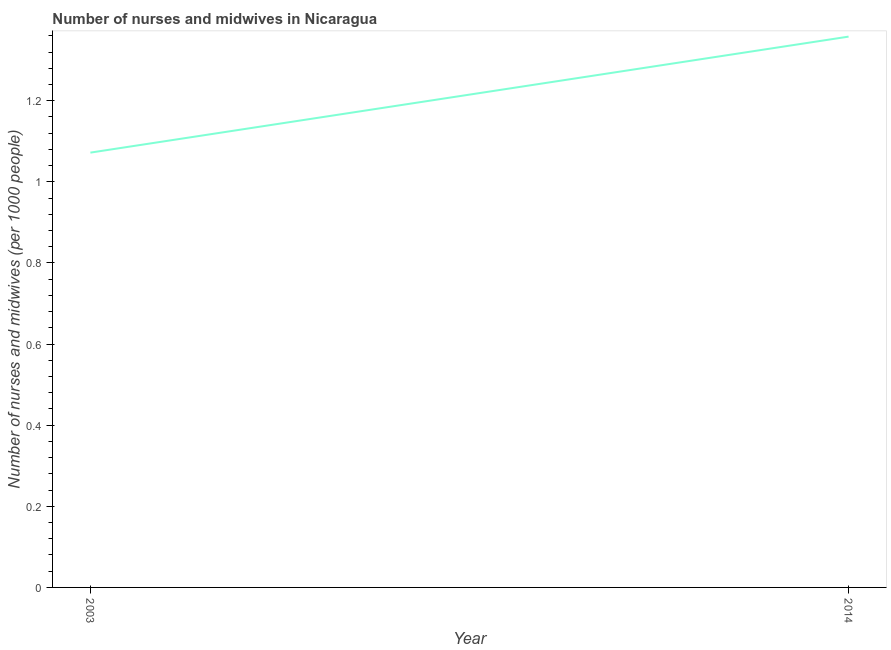What is the number of nurses and midwives in 2003?
Provide a short and direct response. 1.07. Across all years, what is the maximum number of nurses and midwives?
Your answer should be very brief. 1.36. Across all years, what is the minimum number of nurses and midwives?
Give a very brief answer. 1.07. What is the sum of the number of nurses and midwives?
Provide a succinct answer. 2.43. What is the difference between the number of nurses and midwives in 2003 and 2014?
Offer a terse response. -0.29. What is the average number of nurses and midwives per year?
Keep it short and to the point. 1.22. What is the median number of nurses and midwives?
Keep it short and to the point. 1.22. In how many years, is the number of nurses and midwives greater than 1 ?
Your response must be concise. 2. What is the ratio of the number of nurses and midwives in 2003 to that in 2014?
Your answer should be compact. 0.79. Does the number of nurses and midwives monotonically increase over the years?
Provide a succinct answer. Yes. How many years are there in the graph?
Your answer should be very brief. 2. What is the difference between two consecutive major ticks on the Y-axis?
Provide a succinct answer. 0.2. Does the graph contain grids?
Keep it short and to the point. No. What is the title of the graph?
Offer a terse response. Number of nurses and midwives in Nicaragua. What is the label or title of the X-axis?
Your response must be concise. Year. What is the label or title of the Y-axis?
Your answer should be very brief. Number of nurses and midwives (per 1000 people). What is the Number of nurses and midwives (per 1000 people) in 2003?
Keep it short and to the point. 1.07. What is the Number of nurses and midwives (per 1000 people) of 2014?
Give a very brief answer. 1.36. What is the difference between the Number of nurses and midwives (per 1000 people) in 2003 and 2014?
Provide a short and direct response. -0.29. What is the ratio of the Number of nurses and midwives (per 1000 people) in 2003 to that in 2014?
Your answer should be compact. 0.79. 